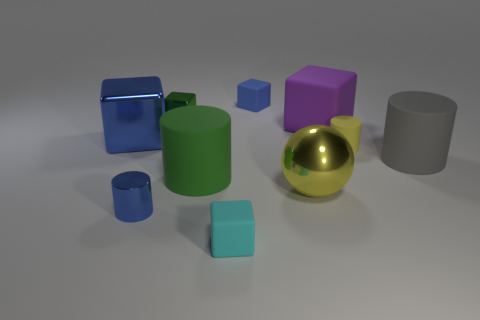The big cylinder that is on the left side of the small matte object that is to the right of the big yellow metal ball is made of what material?
Your answer should be compact. Rubber. What is the shape of the gray object?
Your response must be concise. Cylinder. What material is the blue thing that is the same shape as the gray thing?
Keep it short and to the point. Metal. What number of yellow metal balls have the same size as the cyan block?
Offer a terse response. 0. Are there any tiny green metal blocks behind the big yellow shiny object that is to the right of the small blue cylinder?
Your answer should be compact. Yes. What number of cyan objects are either shiny objects or small cylinders?
Ensure brevity in your answer.  0. The big shiny sphere has what color?
Offer a terse response. Yellow. The other cube that is made of the same material as the big blue block is what size?
Provide a succinct answer. Small. How many green matte objects are the same shape as the tiny blue metal object?
Offer a terse response. 1. Are there any other things that have the same size as the gray matte cylinder?
Give a very brief answer. Yes. 